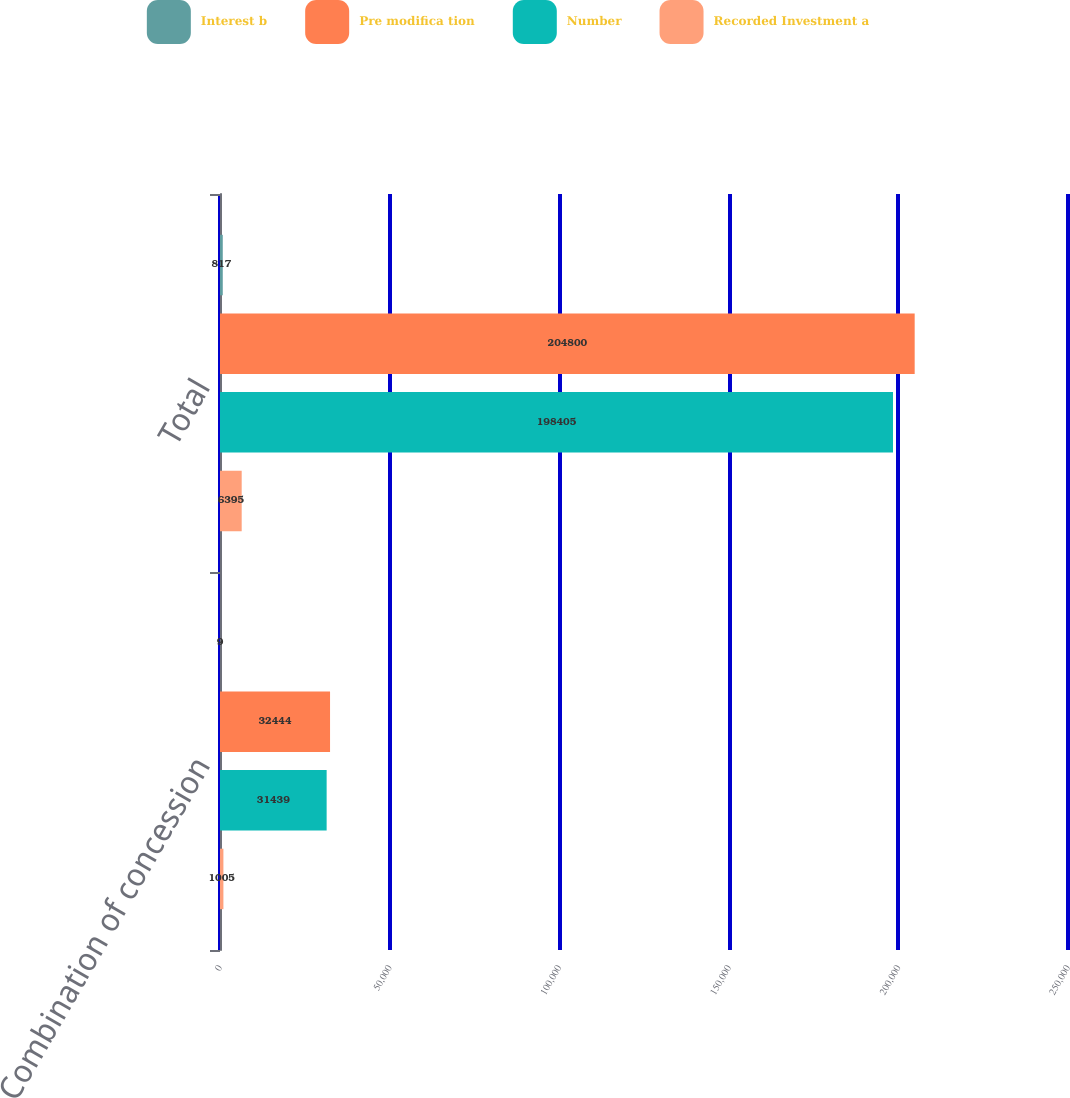Convert chart to OTSL. <chart><loc_0><loc_0><loc_500><loc_500><stacked_bar_chart><ecel><fcel>Combination of concession<fcel>Total<nl><fcel>Interest b<fcel>9<fcel>817<nl><fcel>Pre modifica tion<fcel>32444<fcel>204800<nl><fcel>Number<fcel>31439<fcel>198405<nl><fcel>Recorded Investment a<fcel>1005<fcel>6395<nl></chart> 